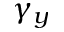<formula> <loc_0><loc_0><loc_500><loc_500>\gamma _ { y }</formula> 